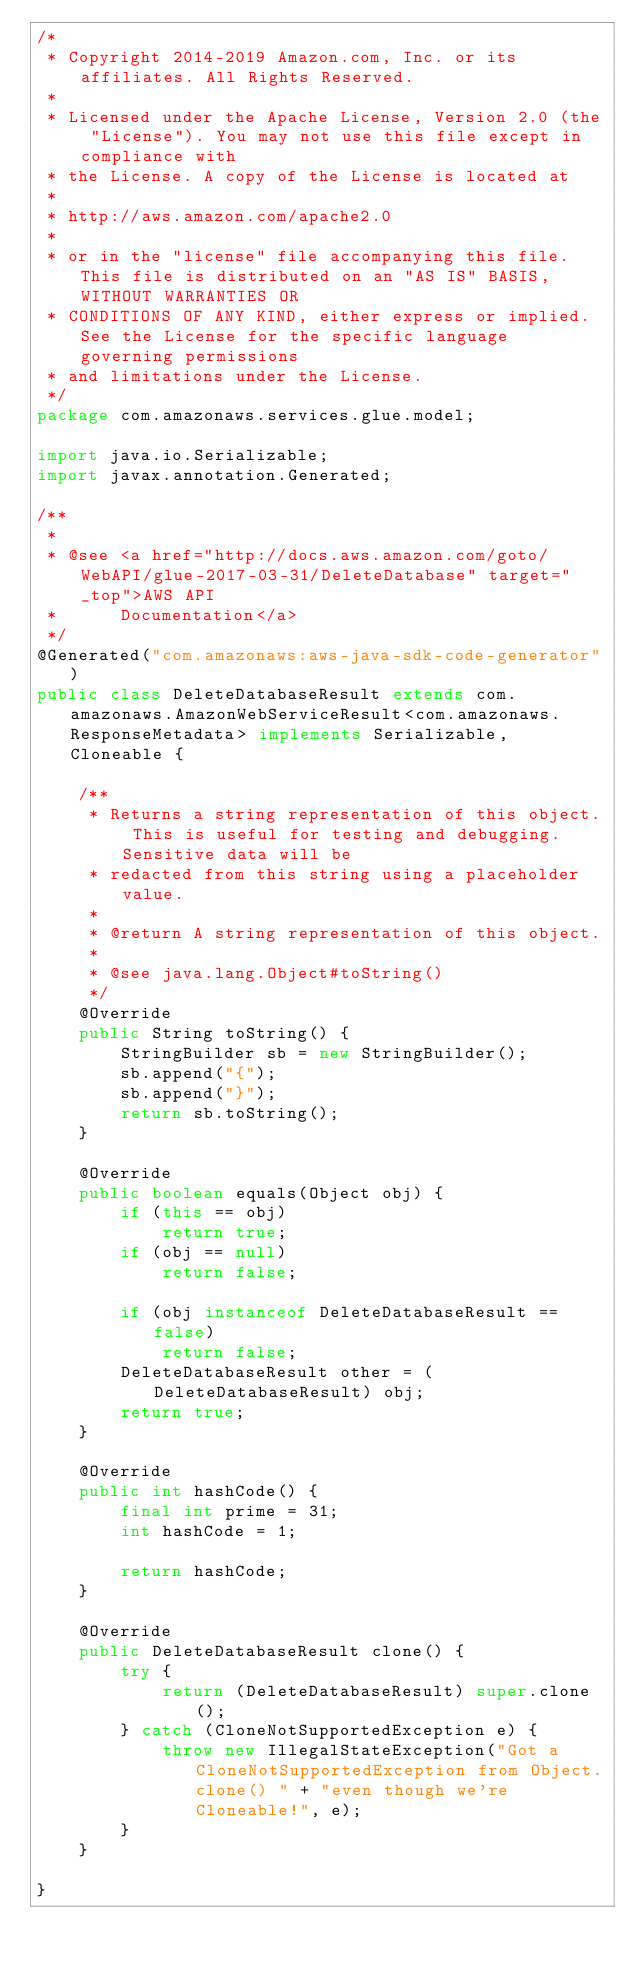Convert code to text. <code><loc_0><loc_0><loc_500><loc_500><_Java_>/*
 * Copyright 2014-2019 Amazon.com, Inc. or its affiliates. All Rights Reserved.
 * 
 * Licensed under the Apache License, Version 2.0 (the "License"). You may not use this file except in compliance with
 * the License. A copy of the License is located at
 * 
 * http://aws.amazon.com/apache2.0
 * 
 * or in the "license" file accompanying this file. This file is distributed on an "AS IS" BASIS, WITHOUT WARRANTIES OR
 * CONDITIONS OF ANY KIND, either express or implied. See the License for the specific language governing permissions
 * and limitations under the License.
 */
package com.amazonaws.services.glue.model;

import java.io.Serializable;
import javax.annotation.Generated;

/**
 * 
 * @see <a href="http://docs.aws.amazon.com/goto/WebAPI/glue-2017-03-31/DeleteDatabase" target="_top">AWS API
 *      Documentation</a>
 */
@Generated("com.amazonaws:aws-java-sdk-code-generator")
public class DeleteDatabaseResult extends com.amazonaws.AmazonWebServiceResult<com.amazonaws.ResponseMetadata> implements Serializable, Cloneable {

    /**
     * Returns a string representation of this object. This is useful for testing and debugging. Sensitive data will be
     * redacted from this string using a placeholder value.
     *
     * @return A string representation of this object.
     *
     * @see java.lang.Object#toString()
     */
    @Override
    public String toString() {
        StringBuilder sb = new StringBuilder();
        sb.append("{");
        sb.append("}");
        return sb.toString();
    }

    @Override
    public boolean equals(Object obj) {
        if (this == obj)
            return true;
        if (obj == null)
            return false;

        if (obj instanceof DeleteDatabaseResult == false)
            return false;
        DeleteDatabaseResult other = (DeleteDatabaseResult) obj;
        return true;
    }

    @Override
    public int hashCode() {
        final int prime = 31;
        int hashCode = 1;

        return hashCode;
    }

    @Override
    public DeleteDatabaseResult clone() {
        try {
            return (DeleteDatabaseResult) super.clone();
        } catch (CloneNotSupportedException e) {
            throw new IllegalStateException("Got a CloneNotSupportedException from Object.clone() " + "even though we're Cloneable!", e);
        }
    }

}
</code> 